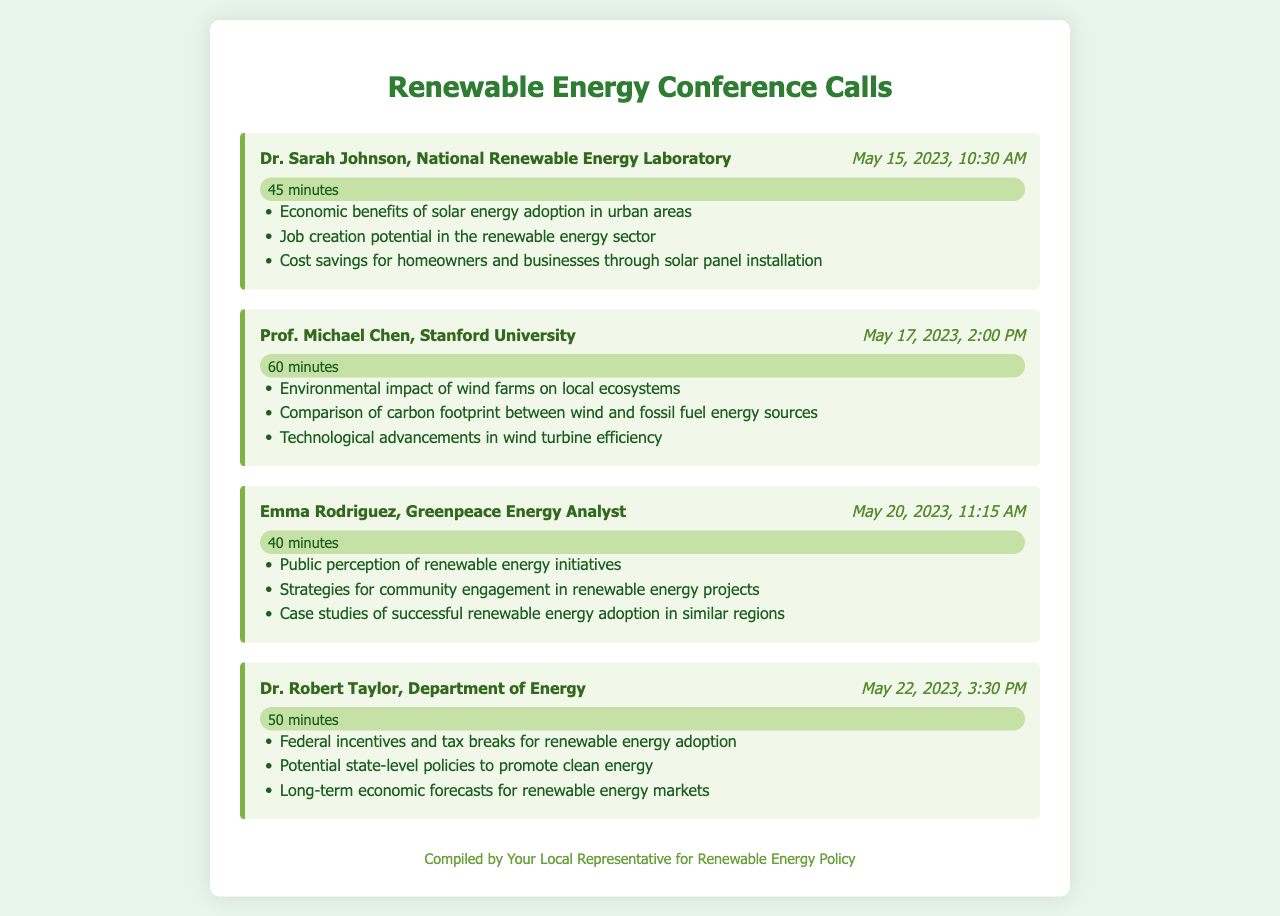What is the name of the expert from the National Renewable Energy Laboratory? The expert from the National Renewable Energy Laboratory is Dr. Sarah Johnson.
Answer: Dr. Sarah Johnson When did the call with Prof. Michael Chen take place? The call with Prof. Michael Chen took place on May 17, 2023, at 2:00 PM.
Answer: May 17, 2023 How long did the call with Emma Rodriguez last? The call with Emma Rodriguez lasted 40 minutes.
Answer: 40 minutes What major topic was discussed in Dr. Robert Taylor's call? One major topic discussed in Dr. Robert Taylor's call was federal incentives and tax breaks for renewable energy adoption.
Answer: Federal incentives and tax breaks for renewable energy adoption Which renewable energy source's environmental impact was discussed by Prof. Michael Chen? Prof. Michael Chen discussed the environmental impact of wind farms.
Answer: Wind farms What is one strategy mentioned by Emma Rodriguez for community engagement? One strategy mentioned by Emma Rodriguez for community engagement is strategies for community engagement in renewable energy projects.
Answer: Strategies for community engagement in renewable energy projects How many minutes long was the call with Dr. Sarah Johnson? The call with Dr. Sarah Johnson was 45 minutes long.
Answer: 45 minutes What is a potential state-level policy topic discussed with Dr. Robert Taylor? A potential state-level policy topic discussed with Dr. Robert Taylor was potential state-level policies to promote clean energy.
Answer: Potential state-level policies to promote clean energy 